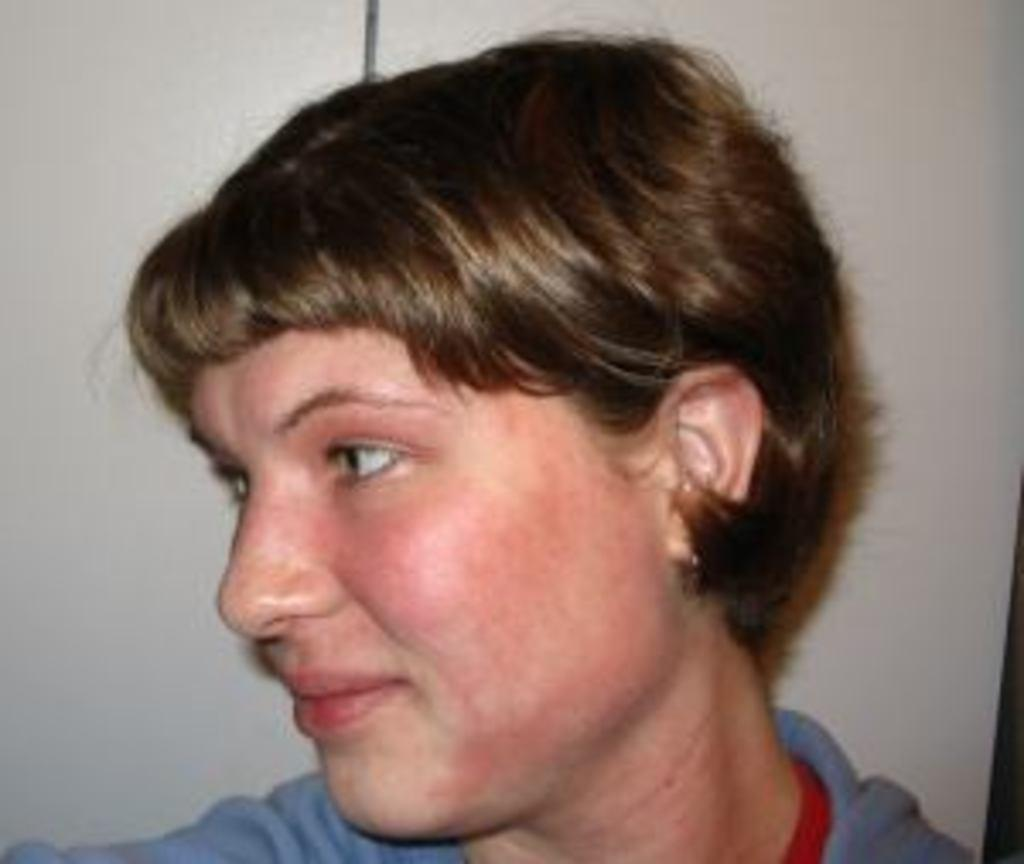How many people are in the image? There is one person in the image. What can be seen in the background of the image? There is a wall visible in the image. What type of space is the person exchanging wires in the image? There is no indication of the person exchanging wires or being in a space in the image. 